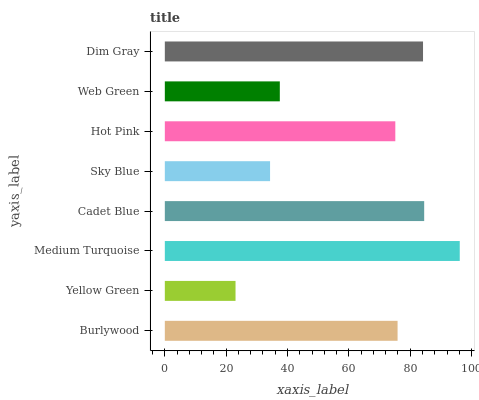Is Yellow Green the minimum?
Answer yes or no. Yes. Is Medium Turquoise the maximum?
Answer yes or no. Yes. Is Medium Turquoise the minimum?
Answer yes or no. No. Is Yellow Green the maximum?
Answer yes or no. No. Is Medium Turquoise greater than Yellow Green?
Answer yes or no. Yes. Is Yellow Green less than Medium Turquoise?
Answer yes or no. Yes. Is Yellow Green greater than Medium Turquoise?
Answer yes or no. No. Is Medium Turquoise less than Yellow Green?
Answer yes or no. No. Is Burlywood the high median?
Answer yes or no. Yes. Is Hot Pink the low median?
Answer yes or no. Yes. Is Web Green the high median?
Answer yes or no. No. Is Medium Turquoise the low median?
Answer yes or no. No. 